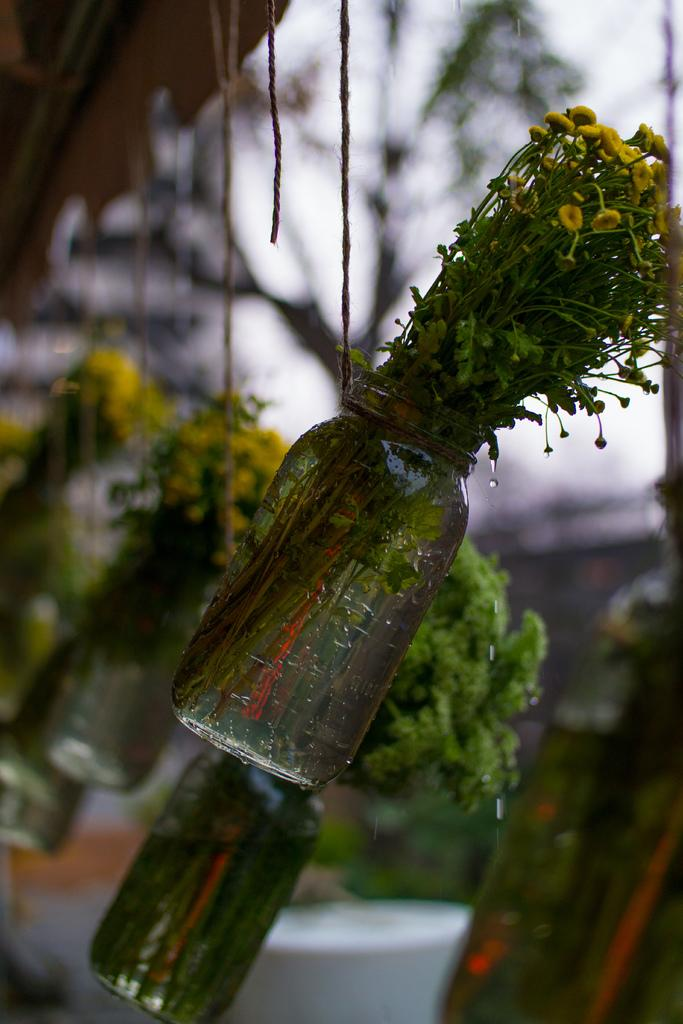What is located in the center of the image? There are bottles in the center of the image. What are the bottles containing? The bottles contain plants. What is visible at the top of the image? The sky is visible at the top of the image. How many chickens are sitting on the dolls in the image? There are no chickens or dolls present in the image. What type of shoe can be seen in the image? There is no shoe visible in the image. 